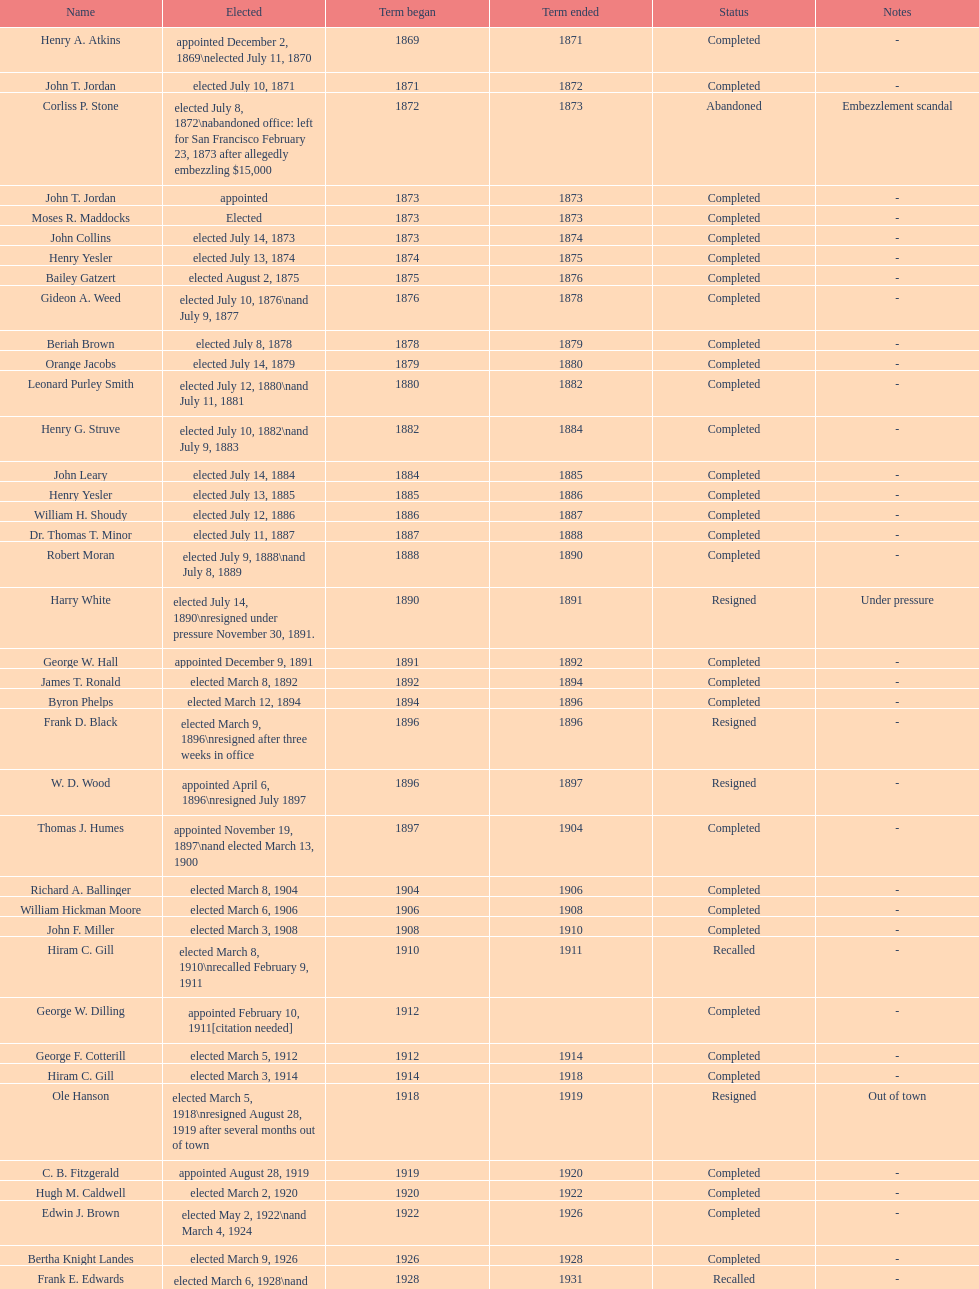Which mayor seattle, washington resigned after only three weeks in office in 1896? Frank D. Black. 